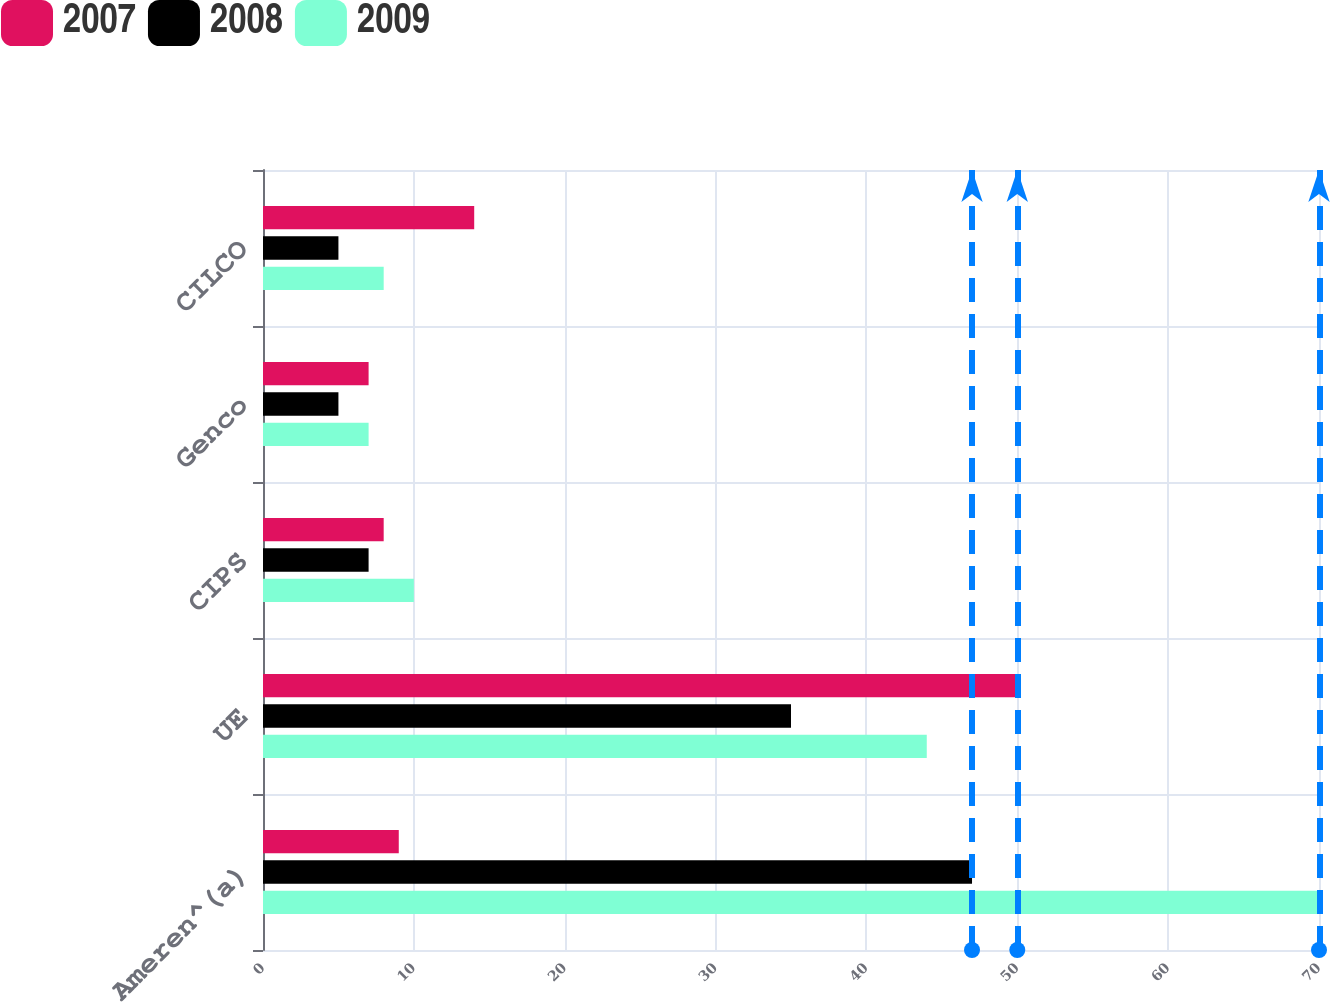<chart> <loc_0><loc_0><loc_500><loc_500><stacked_bar_chart><ecel><fcel>Ameren^(a)<fcel>UE<fcel>CIPS<fcel>Genco<fcel>CILCO<nl><fcel>2007<fcel>9<fcel>50<fcel>8<fcel>7<fcel>14<nl><fcel>2008<fcel>47<fcel>35<fcel>7<fcel>5<fcel>5<nl><fcel>2009<fcel>70<fcel>44<fcel>10<fcel>7<fcel>8<nl></chart> 